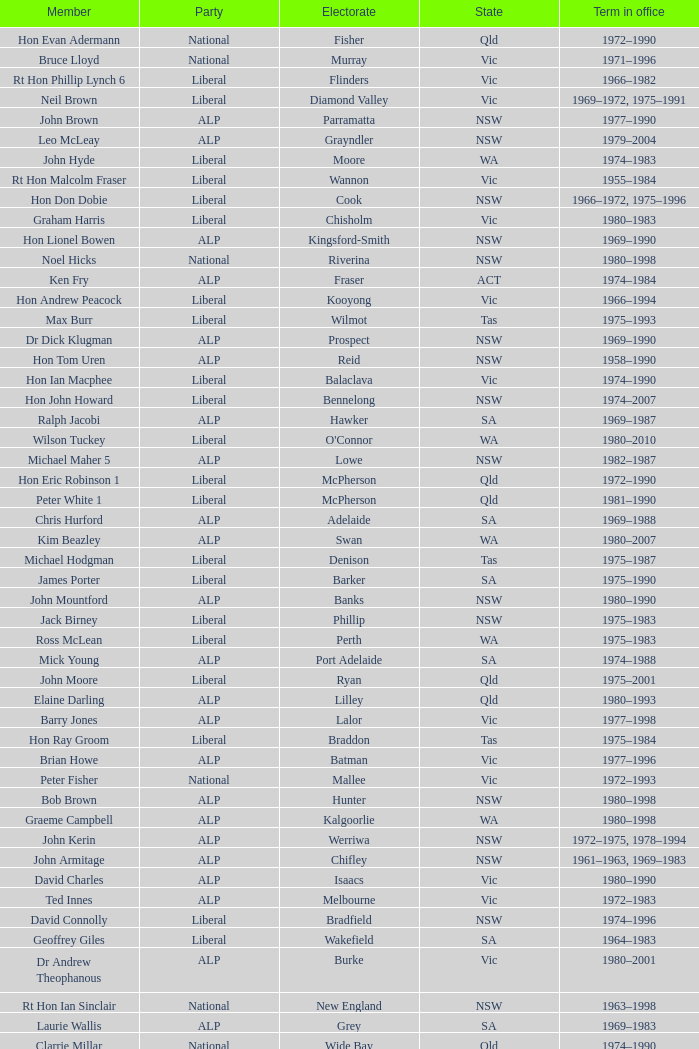What party is Mick Young a member of? ALP. 